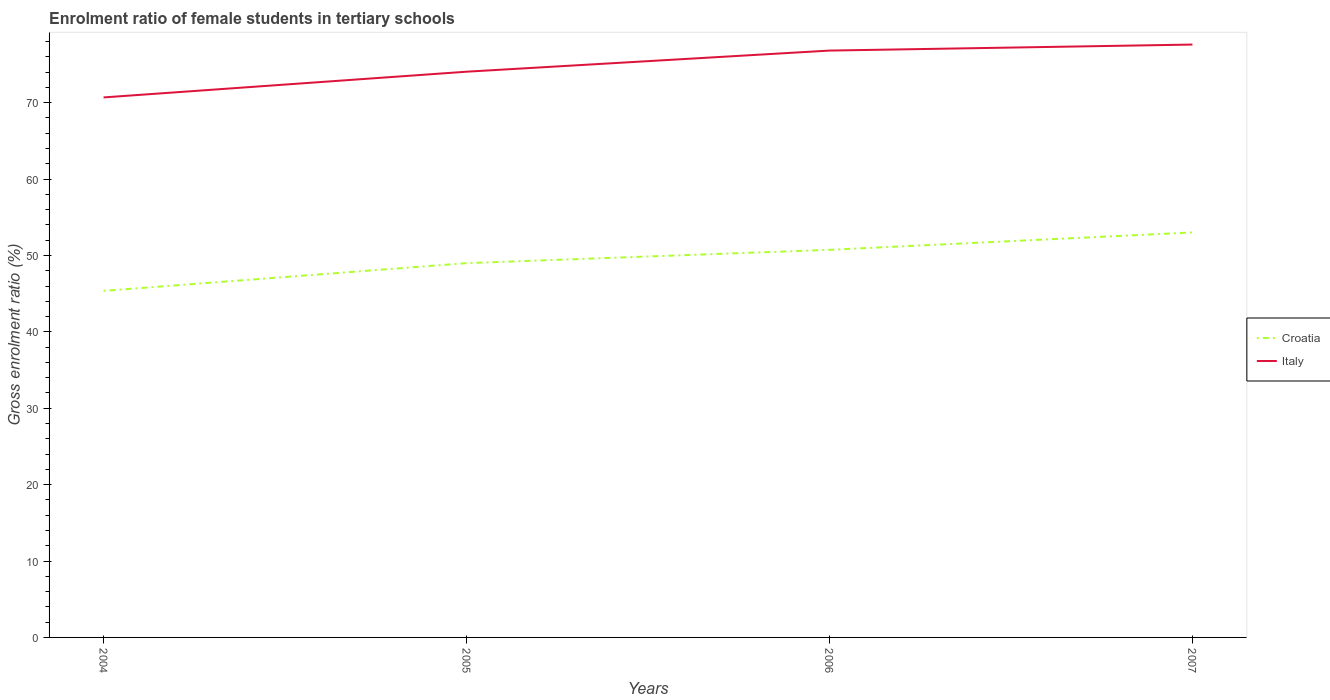Across all years, what is the maximum enrolment ratio of female students in tertiary schools in Croatia?
Ensure brevity in your answer.  45.36. In which year was the enrolment ratio of female students in tertiary schools in Italy maximum?
Your response must be concise. 2004. What is the total enrolment ratio of female students in tertiary schools in Italy in the graph?
Ensure brevity in your answer.  -3.55. What is the difference between the highest and the second highest enrolment ratio of female students in tertiary schools in Croatia?
Make the answer very short. 7.65. What is the difference between the highest and the lowest enrolment ratio of female students in tertiary schools in Italy?
Keep it short and to the point. 2. How many lines are there?
Your response must be concise. 2. How many years are there in the graph?
Your answer should be very brief. 4. Are the values on the major ticks of Y-axis written in scientific E-notation?
Provide a short and direct response. No. Does the graph contain grids?
Your response must be concise. No. What is the title of the graph?
Your answer should be very brief. Enrolment ratio of female students in tertiary schools. Does "Tonga" appear as one of the legend labels in the graph?
Provide a short and direct response. No. What is the label or title of the X-axis?
Make the answer very short. Years. What is the Gross enrolment ratio (%) in Croatia in 2004?
Offer a terse response. 45.36. What is the Gross enrolment ratio (%) of Italy in 2004?
Your response must be concise. 70.68. What is the Gross enrolment ratio (%) in Croatia in 2005?
Keep it short and to the point. 48.99. What is the Gross enrolment ratio (%) in Italy in 2005?
Offer a very short reply. 74.05. What is the Gross enrolment ratio (%) in Croatia in 2006?
Keep it short and to the point. 50.74. What is the Gross enrolment ratio (%) of Italy in 2006?
Your answer should be very brief. 76.82. What is the Gross enrolment ratio (%) of Croatia in 2007?
Provide a succinct answer. 53.01. What is the Gross enrolment ratio (%) of Italy in 2007?
Give a very brief answer. 77.6. Across all years, what is the maximum Gross enrolment ratio (%) of Croatia?
Offer a very short reply. 53.01. Across all years, what is the maximum Gross enrolment ratio (%) in Italy?
Your answer should be compact. 77.6. Across all years, what is the minimum Gross enrolment ratio (%) of Croatia?
Ensure brevity in your answer.  45.36. Across all years, what is the minimum Gross enrolment ratio (%) of Italy?
Offer a very short reply. 70.68. What is the total Gross enrolment ratio (%) of Croatia in the graph?
Offer a terse response. 198.1. What is the total Gross enrolment ratio (%) in Italy in the graph?
Keep it short and to the point. 299.15. What is the difference between the Gross enrolment ratio (%) in Croatia in 2004 and that in 2005?
Provide a succinct answer. -3.63. What is the difference between the Gross enrolment ratio (%) of Italy in 2004 and that in 2005?
Your answer should be compact. -3.37. What is the difference between the Gross enrolment ratio (%) in Croatia in 2004 and that in 2006?
Provide a short and direct response. -5.37. What is the difference between the Gross enrolment ratio (%) of Italy in 2004 and that in 2006?
Your answer should be compact. -6.13. What is the difference between the Gross enrolment ratio (%) of Croatia in 2004 and that in 2007?
Make the answer very short. -7.65. What is the difference between the Gross enrolment ratio (%) in Italy in 2004 and that in 2007?
Keep it short and to the point. -6.92. What is the difference between the Gross enrolment ratio (%) of Croatia in 2005 and that in 2006?
Provide a succinct answer. -1.75. What is the difference between the Gross enrolment ratio (%) of Italy in 2005 and that in 2006?
Provide a short and direct response. -2.76. What is the difference between the Gross enrolment ratio (%) of Croatia in 2005 and that in 2007?
Keep it short and to the point. -4.02. What is the difference between the Gross enrolment ratio (%) in Italy in 2005 and that in 2007?
Ensure brevity in your answer.  -3.55. What is the difference between the Gross enrolment ratio (%) of Croatia in 2006 and that in 2007?
Your answer should be very brief. -2.28. What is the difference between the Gross enrolment ratio (%) of Italy in 2006 and that in 2007?
Your answer should be compact. -0.79. What is the difference between the Gross enrolment ratio (%) of Croatia in 2004 and the Gross enrolment ratio (%) of Italy in 2005?
Offer a terse response. -28.69. What is the difference between the Gross enrolment ratio (%) of Croatia in 2004 and the Gross enrolment ratio (%) of Italy in 2006?
Your response must be concise. -31.45. What is the difference between the Gross enrolment ratio (%) in Croatia in 2004 and the Gross enrolment ratio (%) in Italy in 2007?
Ensure brevity in your answer.  -32.24. What is the difference between the Gross enrolment ratio (%) of Croatia in 2005 and the Gross enrolment ratio (%) of Italy in 2006?
Provide a succinct answer. -27.83. What is the difference between the Gross enrolment ratio (%) of Croatia in 2005 and the Gross enrolment ratio (%) of Italy in 2007?
Your response must be concise. -28.61. What is the difference between the Gross enrolment ratio (%) of Croatia in 2006 and the Gross enrolment ratio (%) of Italy in 2007?
Give a very brief answer. -26.87. What is the average Gross enrolment ratio (%) of Croatia per year?
Your response must be concise. 49.53. What is the average Gross enrolment ratio (%) of Italy per year?
Ensure brevity in your answer.  74.79. In the year 2004, what is the difference between the Gross enrolment ratio (%) of Croatia and Gross enrolment ratio (%) of Italy?
Offer a terse response. -25.32. In the year 2005, what is the difference between the Gross enrolment ratio (%) of Croatia and Gross enrolment ratio (%) of Italy?
Give a very brief answer. -25.06. In the year 2006, what is the difference between the Gross enrolment ratio (%) of Croatia and Gross enrolment ratio (%) of Italy?
Give a very brief answer. -26.08. In the year 2007, what is the difference between the Gross enrolment ratio (%) in Croatia and Gross enrolment ratio (%) in Italy?
Keep it short and to the point. -24.59. What is the ratio of the Gross enrolment ratio (%) of Croatia in 2004 to that in 2005?
Keep it short and to the point. 0.93. What is the ratio of the Gross enrolment ratio (%) of Italy in 2004 to that in 2005?
Your response must be concise. 0.95. What is the ratio of the Gross enrolment ratio (%) in Croatia in 2004 to that in 2006?
Offer a terse response. 0.89. What is the ratio of the Gross enrolment ratio (%) in Italy in 2004 to that in 2006?
Provide a short and direct response. 0.92. What is the ratio of the Gross enrolment ratio (%) in Croatia in 2004 to that in 2007?
Ensure brevity in your answer.  0.86. What is the ratio of the Gross enrolment ratio (%) in Italy in 2004 to that in 2007?
Your answer should be very brief. 0.91. What is the ratio of the Gross enrolment ratio (%) in Croatia in 2005 to that in 2006?
Offer a very short reply. 0.97. What is the ratio of the Gross enrolment ratio (%) of Italy in 2005 to that in 2006?
Give a very brief answer. 0.96. What is the ratio of the Gross enrolment ratio (%) of Croatia in 2005 to that in 2007?
Your answer should be compact. 0.92. What is the ratio of the Gross enrolment ratio (%) in Italy in 2005 to that in 2007?
Your answer should be very brief. 0.95. What is the ratio of the Gross enrolment ratio (%) of Croatia in 2006 to that in 2007?
Offer a very short reply. 0.96. What is the difference between the highest and the second highest Gross enrolment ratio (%) in Croatia?
Provide a short and direct response. 2.28. What is the difference between the highest and the second highest Gross enrolment ratio (%) of Italy?
Provide a succinct answer. 0.79. What is the difference between the highest and the lowest Gross enrolment ratio (%) in Croatia?
Offer a very short reply. 7.65. What is the difference between the highest and the lowest Gross enrolment ratio (%) of Italy?
Provide a short and direct response. 6.92. 